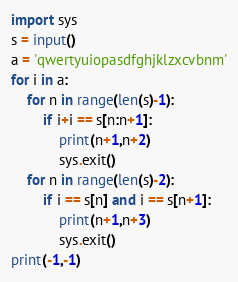<code> <loc_0><loc_0><loc_500><loc_500><_Python_>import sys
s = input()
a = 'qwertyuiopasdfghjklzxcvbnm'
for i in a:
    for n in range(len(s)-1):
        if i+i == s[n:n+1]:
            print(n+1,n+2)
            sys.exit()
    for n in range(len(s)-2):
        if i == s[n] and i == s[n+1]:
            print(n+1,n+3)
            sys.exit()
print(-1,-1)
</code> 